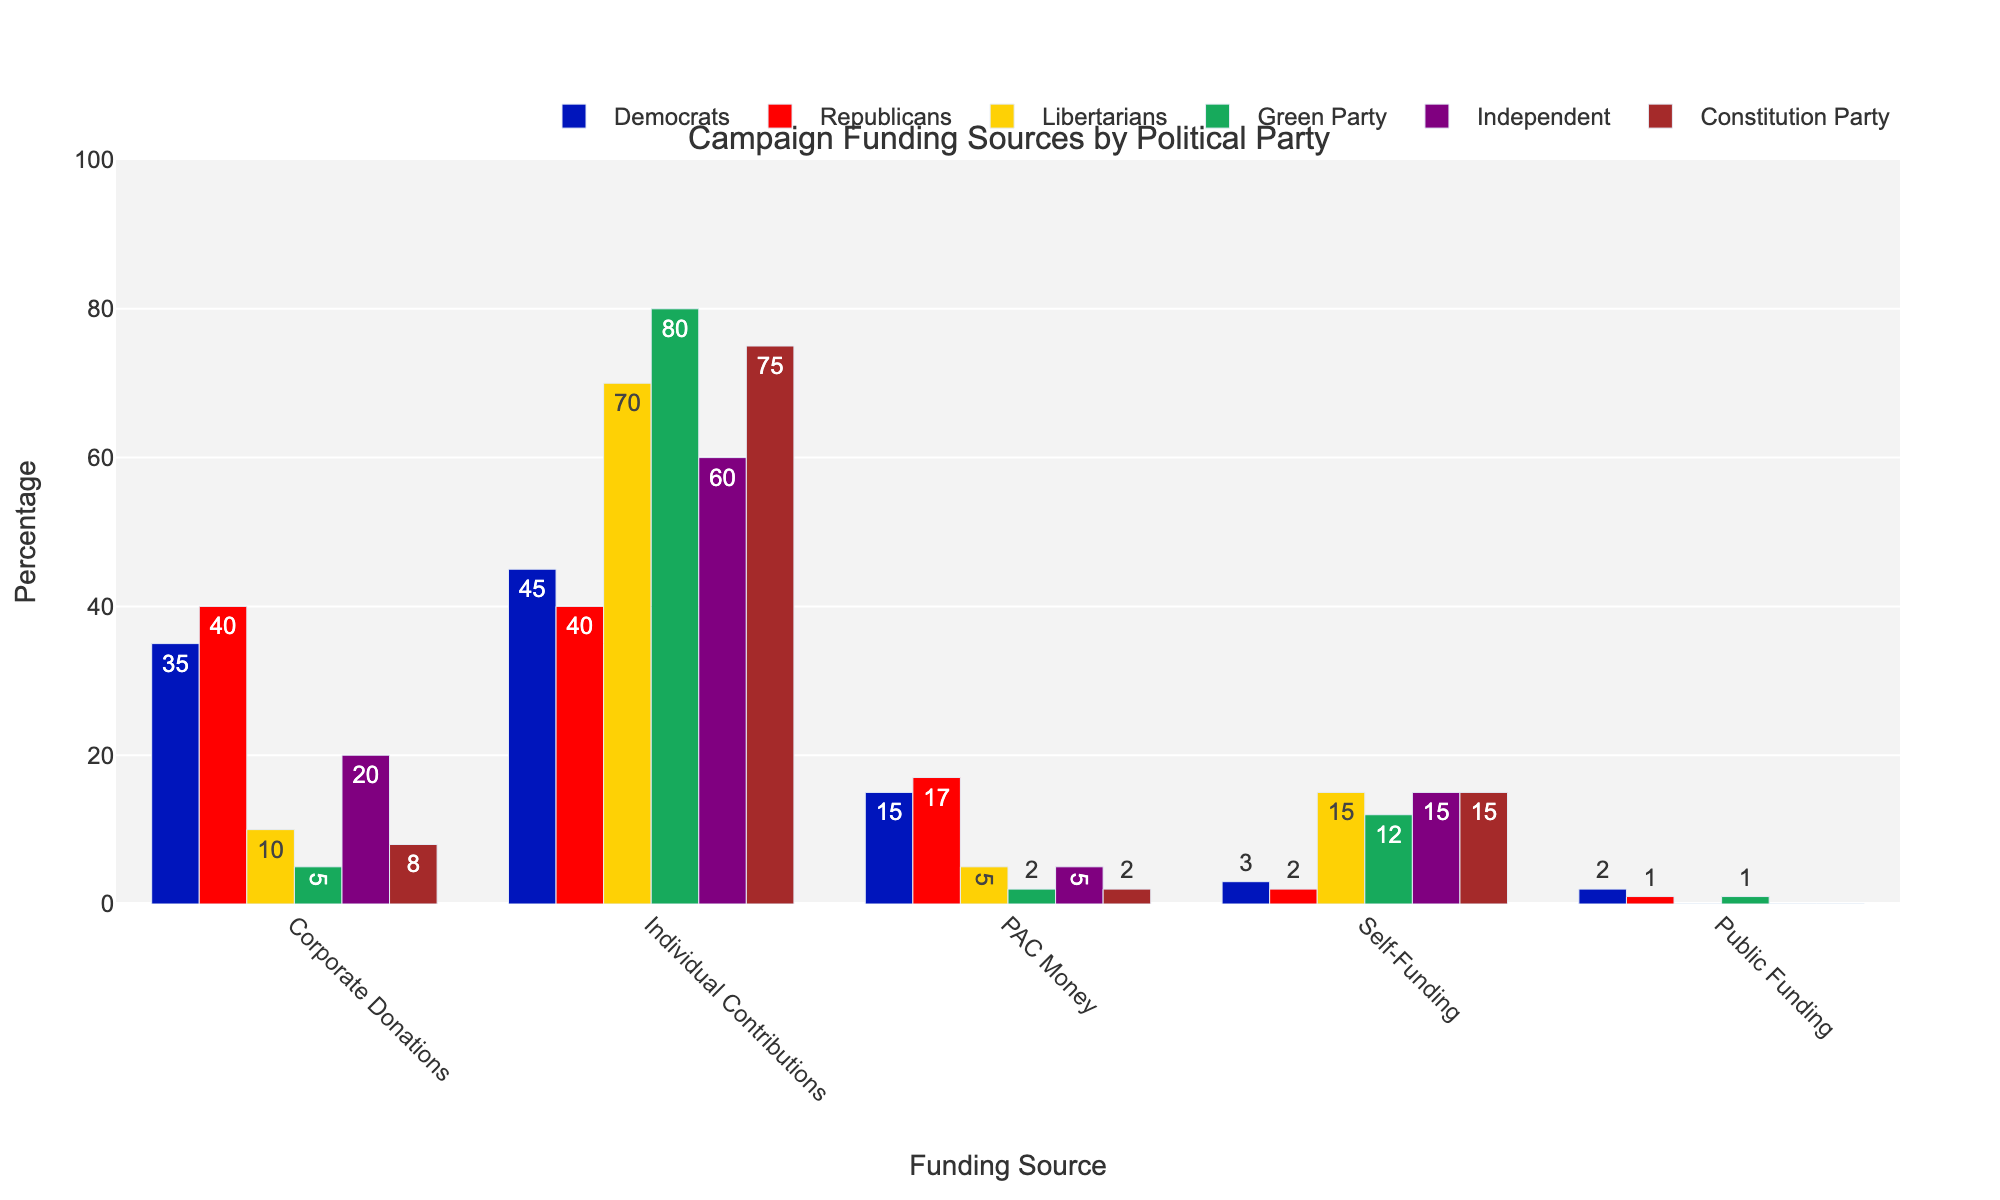Which political party received the highest percentage of individual contributions? The Green Party bar is the tallest in the 'Individual Contributions' category, indicating they received the highest percentage of individual contributions.
Answer: Green Party What is the total percentage of funding from all sources for the Libertarians? Sum the percentages for all funding sources for the Libertarians: 10 (Corporate) + 70 (Individual) + 5 (PAC) + 15 (Self) + 0 (Public) = 100%.
Answer: 100% Which funding source contributed the least to the Democrats' campaign funding? The shortest bar for the Democrats is in the 'Public Funding' category, indicating it is their least contributing source.
Answer: Public Funding How does the percentage of corporate donations for Republicans compare to Democrats? The bar for Republicans shows 40% and for Democrats shows 35% in the 'Corporate Donations' category. Therefore, Republicans received a higher percentage by 5%.
Answer: Republicans received 5% more Between the Independent and Constitution Party, which one received more PAC money? Comparing the heights of the bars in the 'PAC Money' category, both parties received 5%, indicating equal amounts.
Answer: They received the same amount If you sum the PAC money and self-funding percentages for the Green Party, what is the total? Add the percentages: 2% (PAC Money) + 12% (Self-Funding) = 14%.
Answer: 14% Which funding source shows the greatest variability among all parties? Individual Contributions show the most variability based on the bar heights: 45% for Democrats, 40% for Republicans, 70% for Libertarians, 80% for Green Party, 60% for Independent, and 75% for Constitution Party.
Answer: Individual Contributions How much more does the Constitution Party rely on individual contributions compared to corporate donations? Constitution Party has 75% from Individual Contributions and 8% from Corporate Donations. The difference is 75% - 8% = 67%.
Answer: 67% What is the average percentage of self-funding for all parties? Sum the Self-Funding percentages: 3% (Democrats) + 2% (Republicans) + 15% (Libertarians) + 12% (Green Party) + 15% (Independent) + 15% (Constitution Party) = 62%. Divide by 6 parties: 62% / 6 = about 10.3%.
Answer: About 10.3% Which party has the second highest corporate donations? The second highest bar in 'Corporate Donations' is 35% for Democrats, next to 40% for Republicans.
Answer: Democrats 